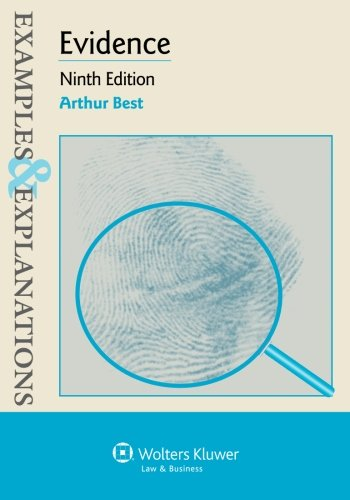What year was this edition of the book published? The ninth edition of 'Examples & Explanations: Evidence', written by Arthur Best, was published in 2018. 